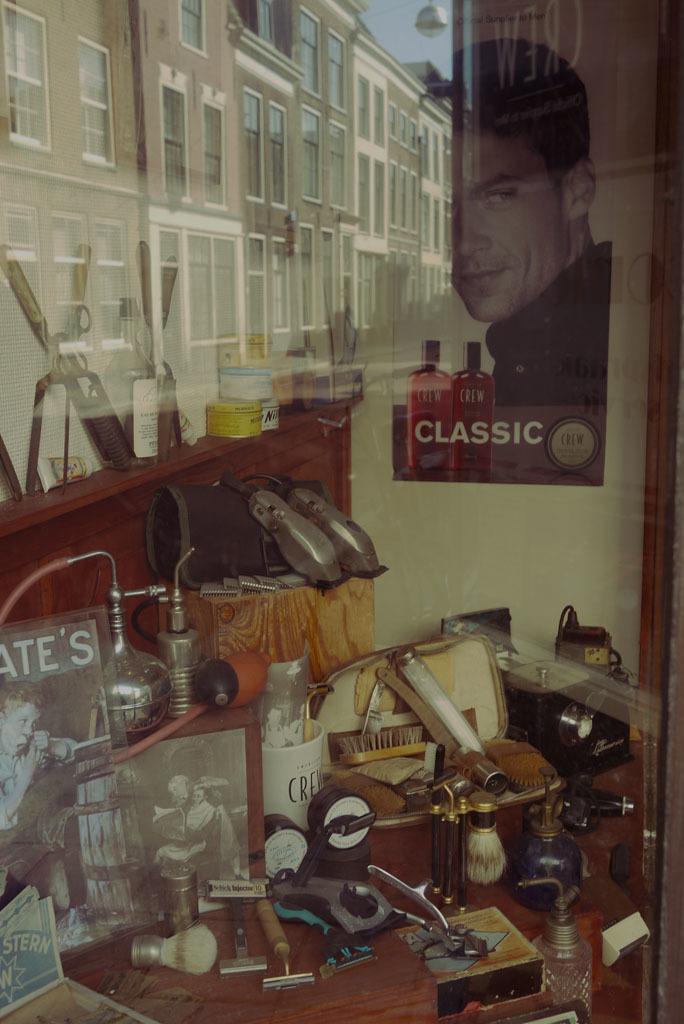What is the first letter on the white mug?
Offer a terse response. C. 